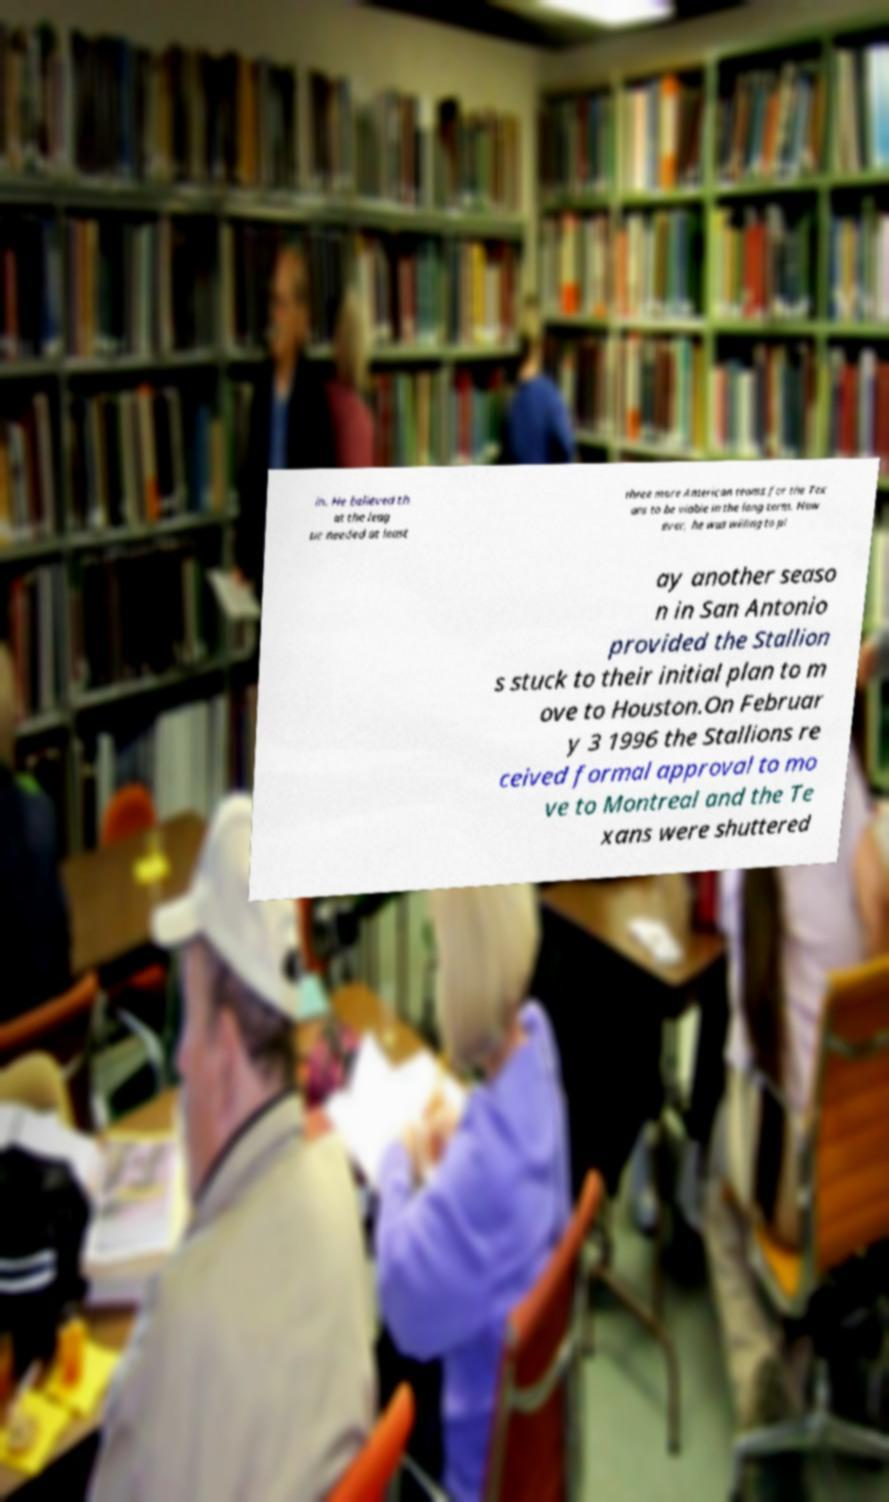What messages or text are displayed in this image? I need them in a readable, typed format. in. He believed th at the leag ue needed at least three more American teams for the Tex ans to be viable in the long term. How ever, he was willing to pl ay another seaso n in San Antonio provided the Stallion s stuck to their initial plan to m ove to Houston.On Februar y 3 1996 the Stallions re ceived formal approval to mo ve to Montreal and the Te xans were shuttered 